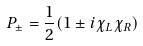<formula> <loc_0><loc_0><loc_500><loc_500>P _ { \pm } = \frac { 1 } { 2 } ( 1 \pm i \chi _ { L } \chi _ { R } )</formula> 